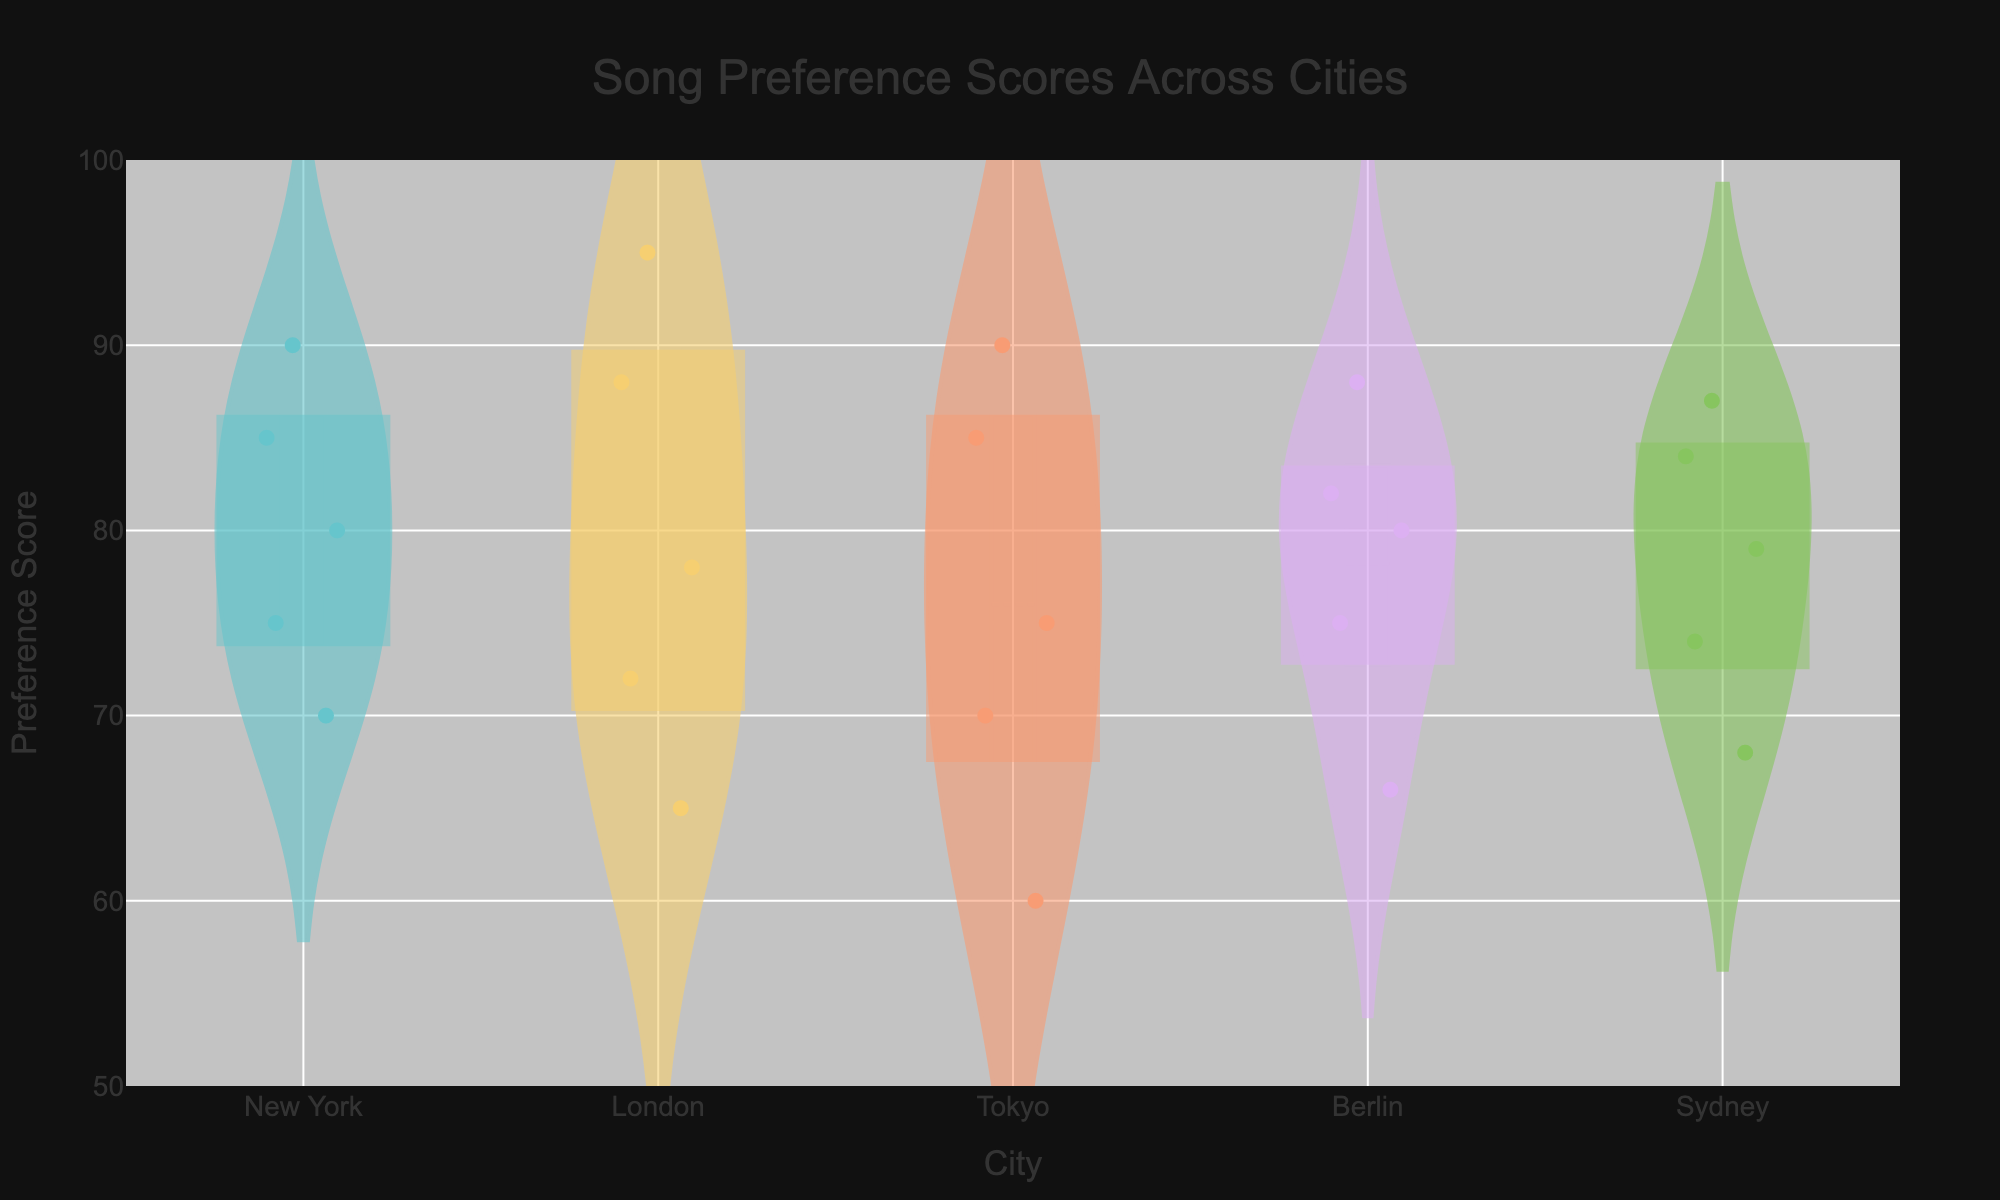what is the title of the figure? The title is generally positioned at the top of the figure. Here, it states "Song Preference Scores Across Cities".
Answer: Song Preference Scores Across Cities How many cities are represented in the figure? The x-axis labels show the cities. By counting these labels, we see there are five cities: New York, London, Tokyo, Berlin, and Sydney.
Answer: 5 Which city has the highest individual song preference score? Look for the highest point among the jittered points or violin plots. Tokyo has the highest score with a preference score of 90 for Hit Song 1.
Answer: Tokyo What is the median preference score for New York? The violin plot shows the median with a line inside the plot. For New York, the median line appears at around 80.
Answer: 80 Compare the preference scores for Hit Song 1 between Tokyo and Berlin. Identify the scores for Hit Song 1 for each city. Tokyo's score is 90, while Berlin's score is 80.
Answer: Tokyo's score is higher Which city has the narrowest distribution of preference scores? The narrowest violin plot indicates the city with the least variation in preference scores. Berlin’s violin plot appears to be the narrowest.
Answer: Berlin Are any of the cities’ mean preference scores approximately equal? The violin plots indicate mean with a thicker horizontal line. Both New York and Sydney have mean scores around 78-79, appearing quite similar.
Answer: New York and Sydney Which song has the highest variability in preference scores in London? For London, observe which song preference scores have the largest spread in jittered points. Hit Song 3 shows the highest variability.
Answer: Hit Song 3 Which city has the lowest minimum preference score visible on the plot? Locate the lowest jittered point for all cities. London has the lowest minimum with a score of 65.
Answer: London 